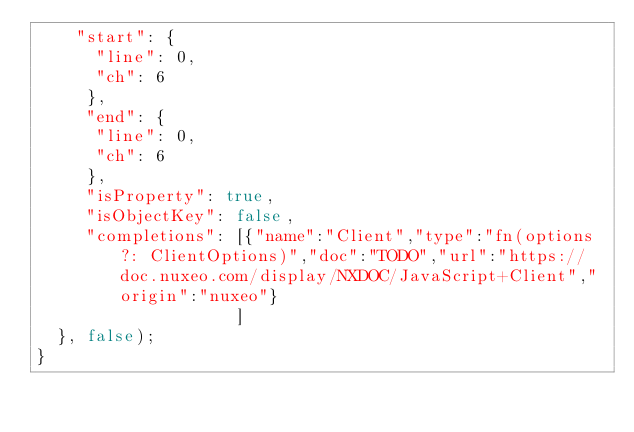Convert code to text. <code><loc_0><loc_0><loc_500><loc_500><_JavaScript_>    "start": {
      "line": 0,
      "ch": 6
     },
     "end": {
      "line": 0,
      "ch": 6
     },
     "isProperty": true,
     "isObjectKey": false,
     "completions": [{"name":"Client","type":"fn(options?: ClientOptions)","doc":"TODO","url":"https://doc.nuxeo.com/display/NXDOC/JavaScript+Client","origin":"nuxeo"}
                    ]
  }, false);
}</code> 